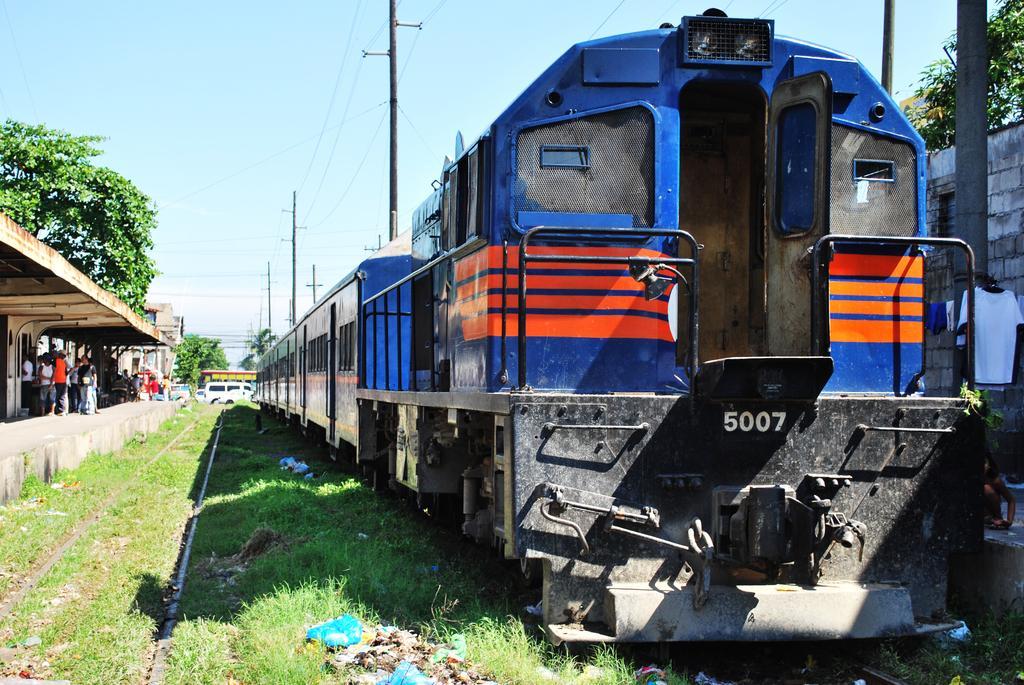Could you give a brief overview of what you see in this image? In this image we can see a train on the track. At the bottom there is grass. On the left we can see people standing on the platform and there are trees. In the center there are poles. At the top there are wires and sky. 